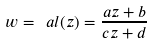Convert formula to latex. <formula><loc_0><loc_0><loc_500><loc_500>w = \ a l ( z ) = \frac { a z + b } { c z + d }</formula> 